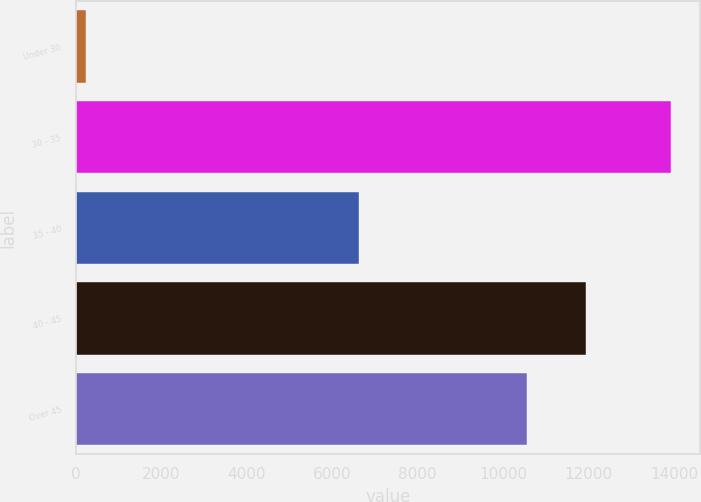Convert chart. <chart><loc_0><loc_0><loc_500><loc_500><bar_chart><fcel>Under 30<fcel>30 - 35<fcel>35 - 40<fcel>40 - 45<fcel>Over 45<nl><fcel>233<fcel>13915<fcel>6625<fcel>11937.2<fcel>10569<nl></chart> 